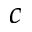<formula> <loc_0><loc_0><loc_500><loc_500>c</formula> 